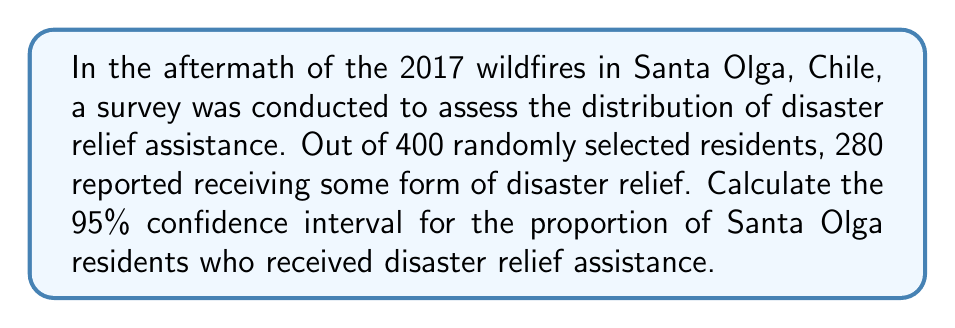Show me your answer to this math problem. Let's approach this step-by-step:

1) First, we need to calculate the sample proportion:
   $\hat{p} = \frac{\text{number of successes}}{\text{sample size}} = \frac{280}{400} = 0.7$

2) The formula for the confidence interval of a proportion is:
   $$\hat{p} \pm z^* \sqrt{\frac{\hat{p}(1-\hat{p})}{n}}$$
   where $z^*$ is the critical value for the desired confidence level.

3) For a 95% confidence interval, $z^* = 1.96$

4) Now, let's substitute our values:
   $n = 400$
   $\hat{p} = 0.7$

5) Calculate the standard error:
   $$SE = \sqrt{\frac{\hat{p}(1-\hat{p})}{n}} = \sqrt{\frac{0.7(1-0.7)}{400}} = \sqrt{\frac{0.21}{400}} = 0.0229$$

6) Now we can calculate the margin of error:
   $$ME = z^* \times SE = 1.96 \times 0.0229 = 0.0449$$

7) Finally, we can compute the confidence interval:
   $0.7 \pm 0.0449$
   
   Lower bound: $0.7 - 0.0449 = 0.6551$
   Upper bound: $0.7 + 0.0449 = 0.7449$

Therefore, we are 95% confident that the true proportion of Santa Olga residents who received disaster relief assistance is between 0.6551 and 0.7449, or between 65.51% and 74.49%.
Answer: (0.6551, 0.7449) 